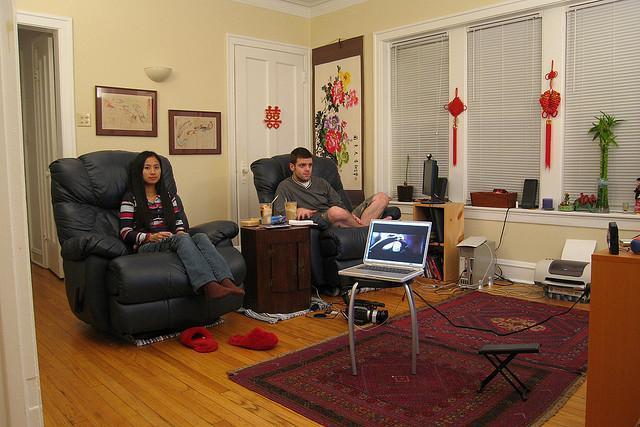How many people are here?
Give a very brief answer. 2. How many mugs are on the table?
Give a very brief answer. 2. How many chairs in the picture?
Give a very brief answer. 2. How many chairs can you see?
Give a very brief answer. 2. How many people are there?
Give a very brief answer. 2. 